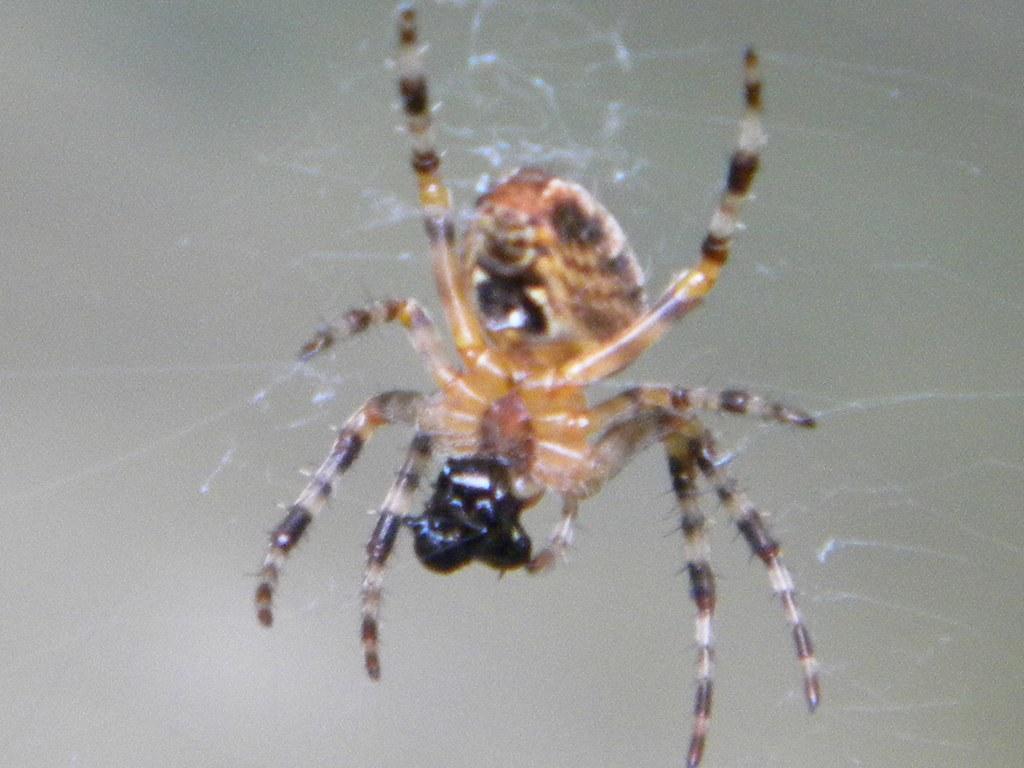Please provide a concise description of this image. In this image I can see the spider and the spider web. I can see the spider is in brown and black color. I can see an ash color background. 